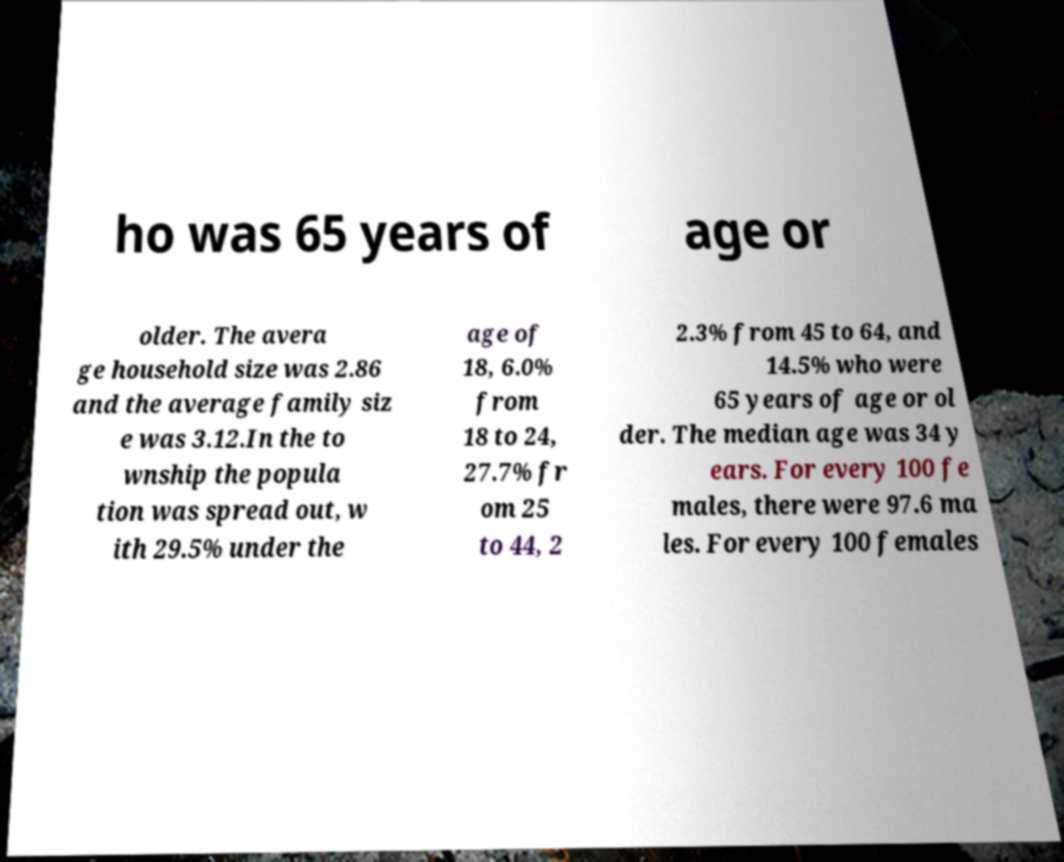What messages or text are displayed in this image? I need them in a readable, typed format. ho was 65 years of age or older. The avera ge household size was 2.86 and the average family siz e was 3.12.In the to wnship the popula tion was spread out, w ith 29.5% under the age of 18, 6.0% from 18 to 24, 27.7% fr om 25 to 44, 2 2.3% from 45 to 64, and 14.5% who were 65 years of age or ol der. The median age was 34 y ears. For every 100 fe males, there were 97.6 ma les. For every 100 females 